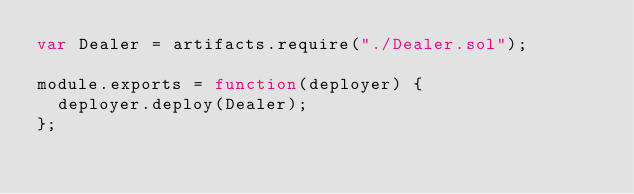<code> <loc_0><loc_0><loc_500><loc_500><_JavaScript_>var Dealer = artifacts.require("./Dealer.sol");

module.exports = function(deployer) {
  deployer.deploy(Dealer);
};
</code> 